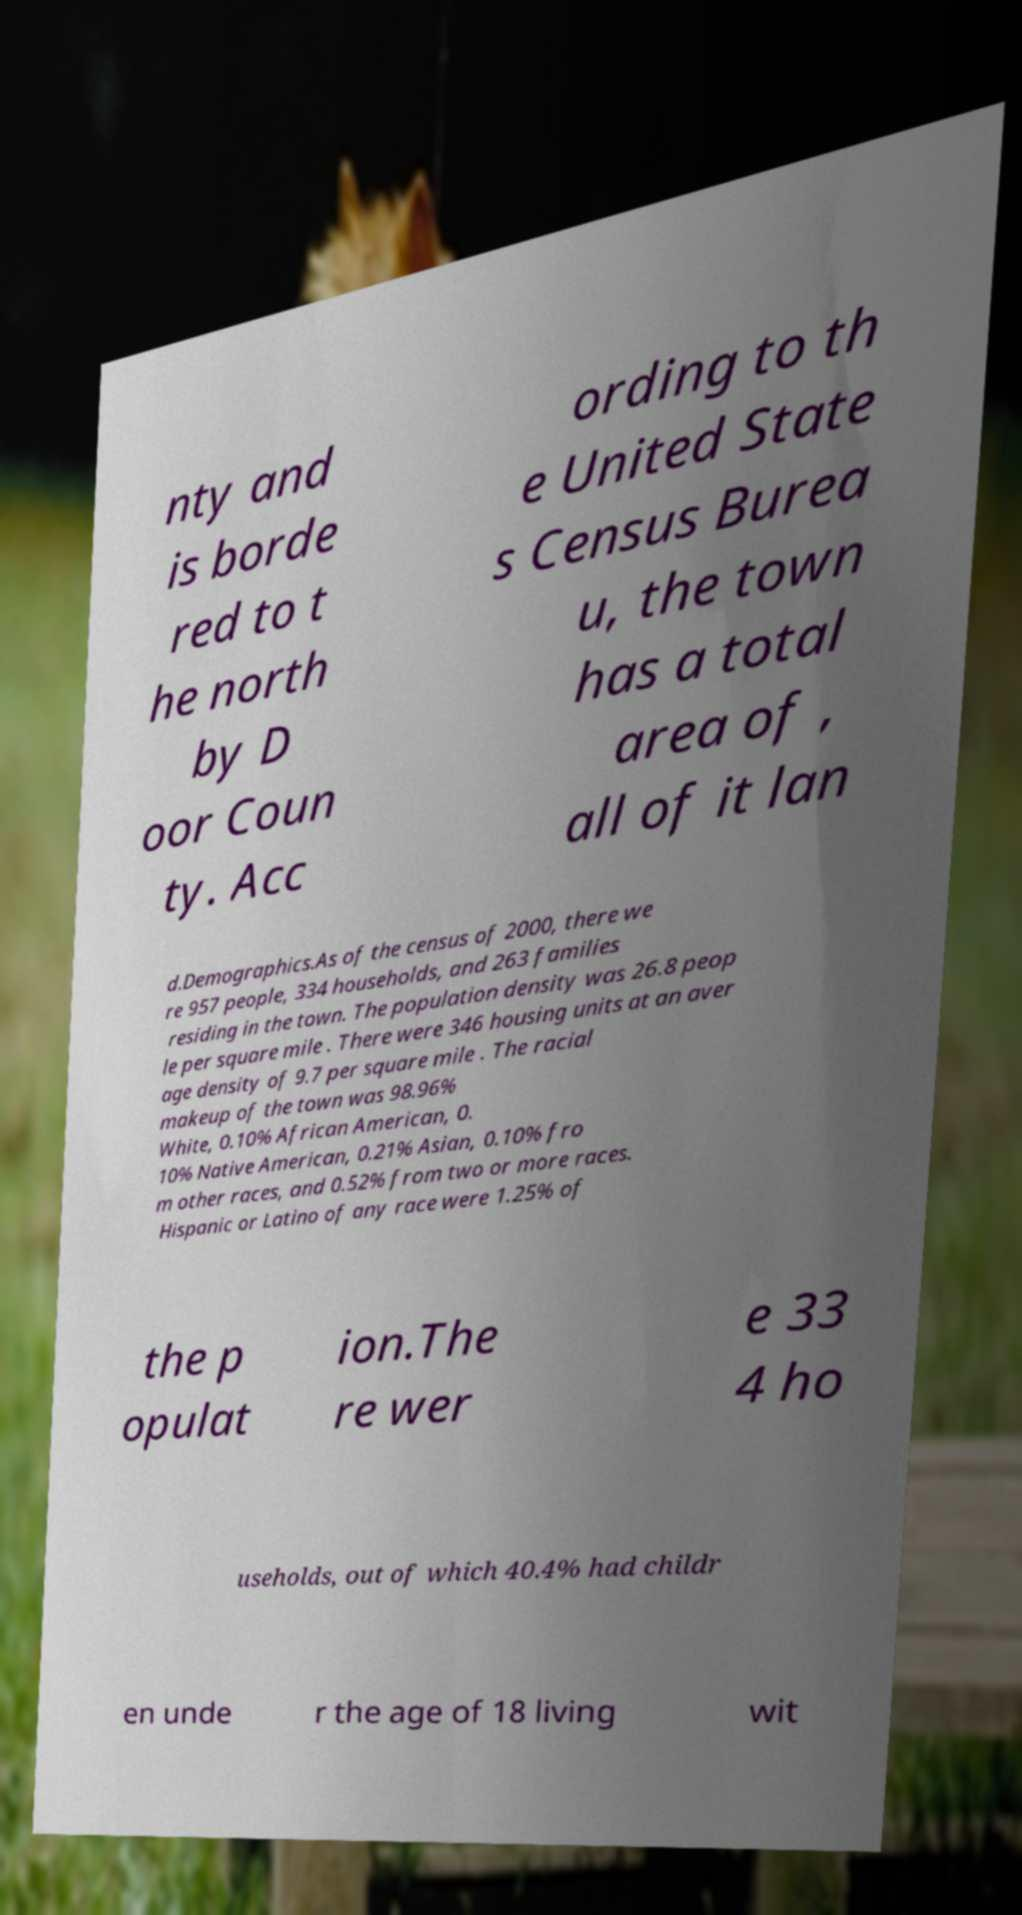I need the written content from this picture converted into text. Can you do that? nty and is borde red to t he north by D oor Coun ty. Acc ording to th e United State s Census Burea u, the town has a total area of , all of it lan d.Demographics.As of the census of 2000, there we re 957 people, 334 households, and 263 families residing in the town. The population density was 26.8 peop le per square mile . There were 346 housing units at an aver age density of 9.7 per square mile . The racial makeup of the town was 98.96% White, 0.10% African American, 0. 10% Native American, 0.21% Asian, 0.10% fro m other races, and 0.52% from two or more races. Hispanic or Latino of any race were 1.25% of the p opulat ion.The re wer e 33 4 ho useholds, out of which 40.4% had childr en unde r the age of 18 living wit 